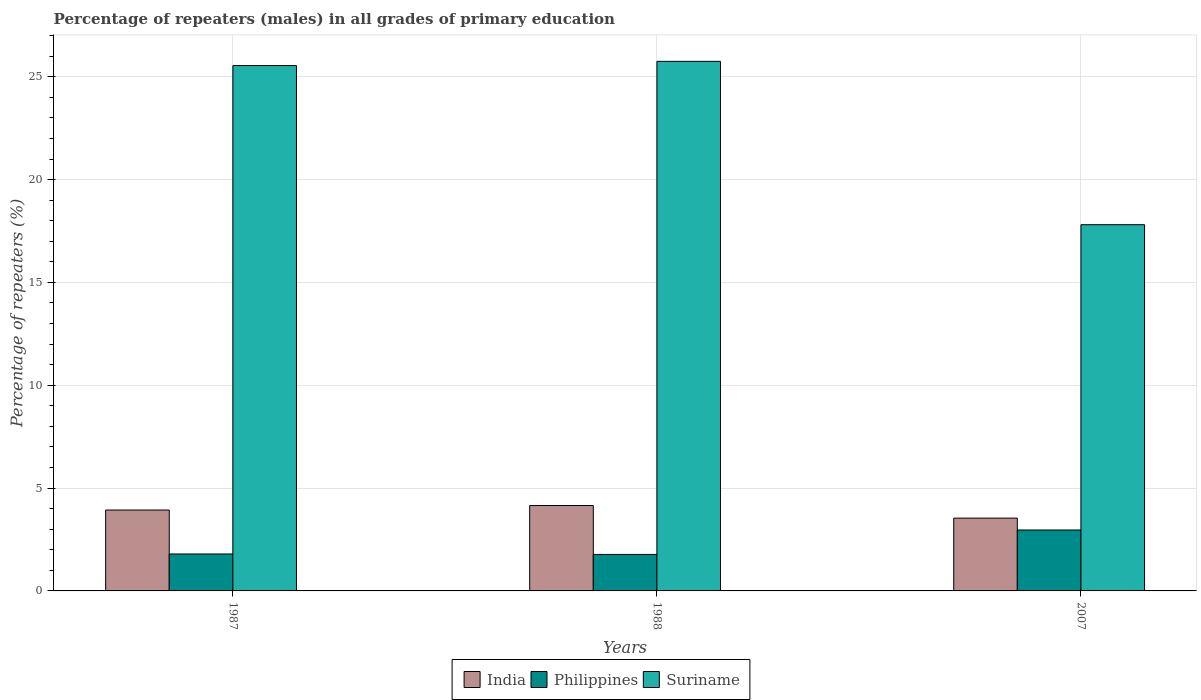How many groups of bars are there?
Provide a succinct answer. 3. What is the label of the 1st group of bars from the left?
Make the answer very short. 1987. What is the percentage of repeaters (males) in Philippines in 1988?
Your response must be concise. 1.77. Across all years, what is the maximum percentage of repeaters (males) in Philippines?
Ensure brevity in your answer.  2.96. Across all years, what is the minimum percentage of repeaters (males) in Philippines?
Make the answer very short. 1.77. What is the total percentage of repeaters (males) in Suriname in the graph?
Make the answer very short. 69.1. What is the difference between the percentage of repeaters (males) in India in 1987 and that in 1988?
Your answer should be very brief. -0.22. What is the difference between the percentage of repeaters (males) in Philippines in 1988 and the percentage of repeaters (males) in India in 2007?
Make the answer very short. -1.77. What is the average percentage of repeaters (males) in Philippines per year?
Provide a short and direct response. 2.18. In the year 1988, what is the difference between the percentage of repeaters (males) in Philippines and percentage of repeaters (males) in Suriname?
Offer a very short reply. -23.97. What is the ratio of the percentage of repeaters (males) in Philippines in 1987 to that in 1988?
Provide a succinct answer. 1.01. Is the difference between the percentage of repeaters (males) in Philippines in 1988 and 2007 greater than the difference between the percentage of repeaters (males) in Suriname in 1988 and 2007?
Offer a very short reply. No. What is the difference between the highest and the second highest percentage of repeaters (males) in Philippines?
Keep it short and to the point. 1.17. What is the difference between the highest and the lowest percentage of repeaters (males) in India?
Your response must be concise. 0.61. Is the sum of the percentage of repeaters (males) in Suriname in 1987 and 1988 greater than the maximum percentage of repeaters (males) in India across all years?
Your response must be concise. Yes. What does the 3rd bar from the left in 2007 represents?
Provide a succinct answer. Suriname. What does the 1st bar from the right in 1987 represents?
Your answer should be very brief. Suriname. How many bars are there?
Offer a very short reply. 9. Are all the bars in the graph horizontal?
Make the answer very short. No. What is the difference between two consecutive major ticks on the Y-axis?
Offer a very short reply. 5. Does the graph contain any zero values?
Provide a short and direct response. No. Does the graph contain grids?
Your answer should be very brief. Yes. How are the legend labels stacked?
Keep it short and to the point. Horizontal. What is the title of the graph?
Your answer should be very brief. Percentage of repeaters (males) in all grades of primary education. Does "Tanzania" appear as one of the legend labels in the graph?
Your answer should be very brief. No. What is the label or title of the Y-axis?
Your answer should be compact. Percentage of repeaters (%). What is the Percentage of repeaters (%) in India in 1987?
Offer a terse response. 3.93. What is the Percentage of repeaters (%) of Philippines in 1987?
Your answer should be compact. 1.8. What is the Percentage of repeaters (%) in Suriname in 1987?
Ensure brevity in your answer.  25.54. What is the Percentage of repeaters (%) of India in 1988?
Make the answer very short. 4.15. What is the Percentage of repeaters (%) in Philippines in 1988?
Provide a short and direct response. 1.77. What is the Percentage of repeaters (%) of Suriname in 1988?
Provide a short and direct response. 25.75. What is the Percentage of repeaters (%) in India in 2007?
Provide a short and direct response. 3.54. What is the Percentage of repeaters (%) of Philippines in 2007?
Ensure brevity in your answer.  2.96. What is the Percentage of repeaters (%) of Suriname in 2007?
Provide a succinct answer. 17.81. Across all years, what is the maximum Percentage of repeaters (%) in India?
Keep it short and to the point. 4.15. Across all years, what is the maximum Percentage of repeaters (%) of Philippines?
Your response must be concise. 2.96. Across all years, what is the maximum Percentage of repeaters (%) of Suriname?
Ensure brevity in your answer.  25.75. Across all years, what is the minimum Percentage of repeaters (%) in India?
Your answer should be compact. 3.54. Across all years, what is the minimum Percentage of repeaters (%) in Philippines?
Make the answer very short. 1.77. Across all years, what is the minimum Percentage of repeaters (%) of Suriname?
Give a very brief answer. 17.81. What is the total Percentage of repeaters (%) of India in the graph?
Provide a short and direct response. 11.62. What is the total Percentage of repeaters (%) of Philippines in the graph?
Provide a succinct answer. 6.53. What is the total Percentage of repeaters (%) in Suriname in the graph?
Offer a very short reply. 69.1. What is the difference between the Percentage of repeaters (%) in India in 1987 and that in 1988?
Provide a short and direct response. -0.22. What is the difference between the Percentage of repeaters (%) of Philippines in 1987 and that in 1988?
Ensure brevity in your answer.  0.02. What is the difference between the Percentage of repeaters (%) of Suriname in 1987 and that in 1988?
Ensure brevity in your answer.  -0.2. What is the difference between the Percentage of repeaters (%) in India in 1987 and that in 2007?
Keep it short and to the point. 0.39. What is the difference between the Percentage of repeaters (%) in Philippines in 1987 and that in 2007?
Offer a terse response. -1.17. What is the difference between the Percentage of repeaters (%) of Suriname in 1987 and that in 2007?
Keep it short and to the point. 7.74. What is the difference between the Percentage of repeaters (%) of India in 1988 and that in 2007?
Your response must be concise. 0.61. What is the difference between the Percentage of repeaters (%) in Philippines in 1988 and that in 2007?
Keep it short and to the point. -1.19. What is the difference between the Percentage of repeaters (%) of Suriname in 1988 and that in 2007?
Ensure brevity in your answer.  7.94. What is the difference between the Percentage of repeaters (%) of India in 1987 and the Percentage of repeaters (%) of Philippines in 1988?
Your response must be concise. 2.16. What is the difference between the Percentage of repeaters (%) in India in 1987 and the Percentage of repeaters (%) in Suriname in 1988?
Make the answer very short. -21.81. What is the difference between the Percentage of repeaters (%) in Philippines in 1987 and the Percentage of repeaters (%) in Suriname in 1988?
Make the answer very short. -23.95. What is the difference between the Percentage of repeaters (%) in India in 1987 and the Percentage of repeaters (%) in Philippines in 2007?
Your answer should be compact. 0.97. What is the difference between the Percentage of repeaters (%) of India in 1987 and the Percentage of repeaters (%) of Suriname in 2007?
Your response must be concise. -13.87. What is the difference between the Percentage of repeaters (%) in Philippines in 1987 and the Percentage of repeaters (%) in Suriname in 2007?
Ensure brevity in your answer.  -16.01. What is the difference between the Percentage of repeaters (%) in India in 1988 and the Percentage of repeaters (%) in Philippines in 2007?
Provide a succinct answer. 1.19. What is the difference between the Percentage of repeaters (%) of India in 1988 and the Percentage of repeaters (%) of Suriname in 2007?
Ensure brevity in your answer.  -13.65. What is the difference between the Percentage of repeaters (%) of Philippines in 1988 and the Percentage of repeaters (%) of Suriname in 2007?
Your answer should be very brief. -16.03. What is the average Percentage of repeaters (%) in India per year?
Provide a succinct answer. 3.87. What is the average Percentage of repeaters (%) in Philippines per year?
Your answer should be very brief. 2.18. What is the average Percentage of repeaters (%) in Suriname per year?
Provide a short and direct response. 23.03. In the year 1987, what is the difference between the Percentage of repeaters (%) of India and Percentage of repeaters (%) of Philippines?
Make the answer very short. 2.14. In the year 1987, what is the difference between the Percentage of repeaters (%) in India and Percentage of repeaters (%) in Suriname?
Offer a very short reply. -21.61. In the year 1987, what is the difference between the Percentage of repeaters (%) in Philippines and Percentage of repeaters (%) in Suriname?
Keep it short and to the point. -23.75. In the year 1988, what is the difference between the Percentage of repeaters (%) of India and Percentage of repeaters (%) of Philippines?
Offer a terse response. 2.38. In the year 1988, what is the difference between the Percentage of repeaters (%) of India and Percentage of repeaters (%) of Suriname?
Offer a terse response. -21.6. In the year 1988, what is the difference between the Percentage of repeaters (%) of Philippines and Percentage of repeaters (%) of Suriname?
Your response must be concise. -23.97. In the year 2007, what is the difference between the Percentage of repeaters (%) of India and Percentage of repeaters (%) of Philippines?
Your answer should be compact. 0.58. In the year 2007, what is the difference between the Percentage of repeaters (%) of India and Percentage of repeaters (%) of Suriname?
Provide a short and direct response. -14.27. In the year 2007, what is the difference between the Percentage of repeaters (%) of Philippines and Percentage of repeaters (%) of Suriname?
Provide a short and direct response. -14.84. What is the ratio of the Percentage of repeaters (%) in India in 1987 to that in 1988?
Provide a succinct answer. 0.95. What is the ratio of the Percentage of repeaters (%) in India in 1987 to that in 2007?
Provide a succinct answer. 1.11. What is the ratio of the Percentage of repeaters (%) in Philippines in 1987 to that in 2007?
Give a very brief answer. 0.61. What is the ratio of the Percentage of repeaters (%) in Suriname in 1987 to that in 2007?
Ensure brevity in your answer.  1.43. What is the ratio of the Percentage of repeaters (%) in India in 1988 to that in 2007?
Provide a short and direct response. 1.17. What is the ratio of the Percentage of repeaters (%) in Philippines in 1988 to that in 2007?
Offer a terse response. 0.6. What is the ratio of the Percentage of repeaters (%) in Suriname in 1988 to that in 2007?
Your answer should be very brief. 1.45. What is the difference between the highest and the second highest Percentage of repeaters (%) in India?
Keep it short and to the point. 0.22. What is the difference between the highest and the second highest Percentage of repeaters (%) of Philippines?
Offer a very short reply. 1.17. What is the difference between the highest and the second highest Percentage of repeaters (%) of Suriname?
Provide a short and direct response. 0.2. What is the difference between the highest and the lowest Percentage of repeaters (%) in India?
Give a very brief answer. 0.61. What is the difference between the highest and the lowest Percentage of repeaters (%) in Philippines?
Your answer should be very brief. 1.19. What is the difference between the highest and the lowest Percentage of repeaters (%) of Suriname?
Your answer should be very brief. 7.94. 